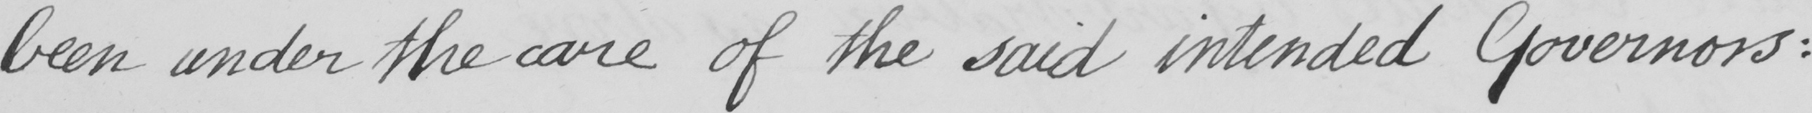Can you read and transcribe this handwriting? been under the care of the said intended Governors : 